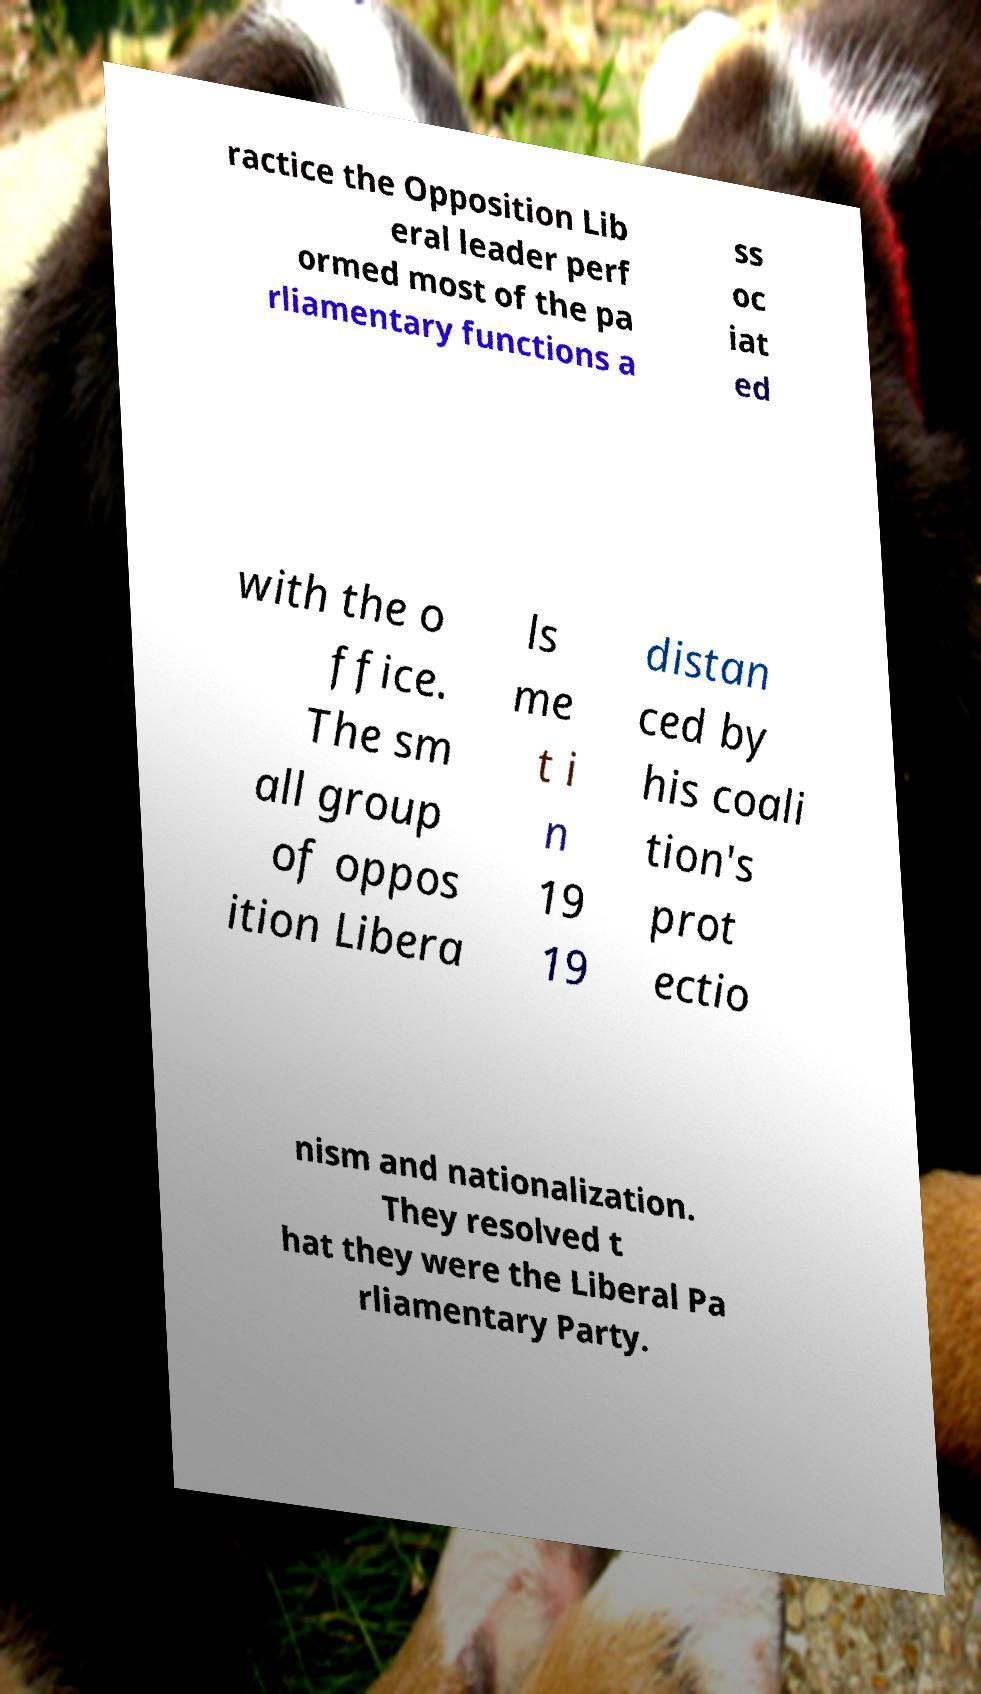Can you read and provide the text displayed in the image?This photo seems to have some interesting text. Can you extract and type it out for me? ractice the Opposition Lib eral leader perf ormed most of the pa rliamentary functions a ss oc iat ed with the o ffice. The sm all group of oppos ition Libera ls me t i n 19 19 distan ced by his coali tion's prot ectio nism and nationalization. They resolved t hat they were the Liberal Pa rliamentary Party. 